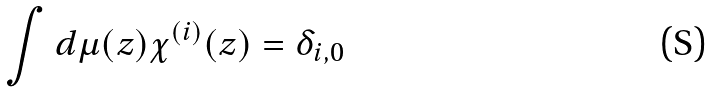Convert formula to latex. <formula><loc_0><loc_0><loc_500><loc_500>\int d \mu ( z ) \chi ^ { ( i ) } ( z ) = \delta _ { i , 0 }</formula> 